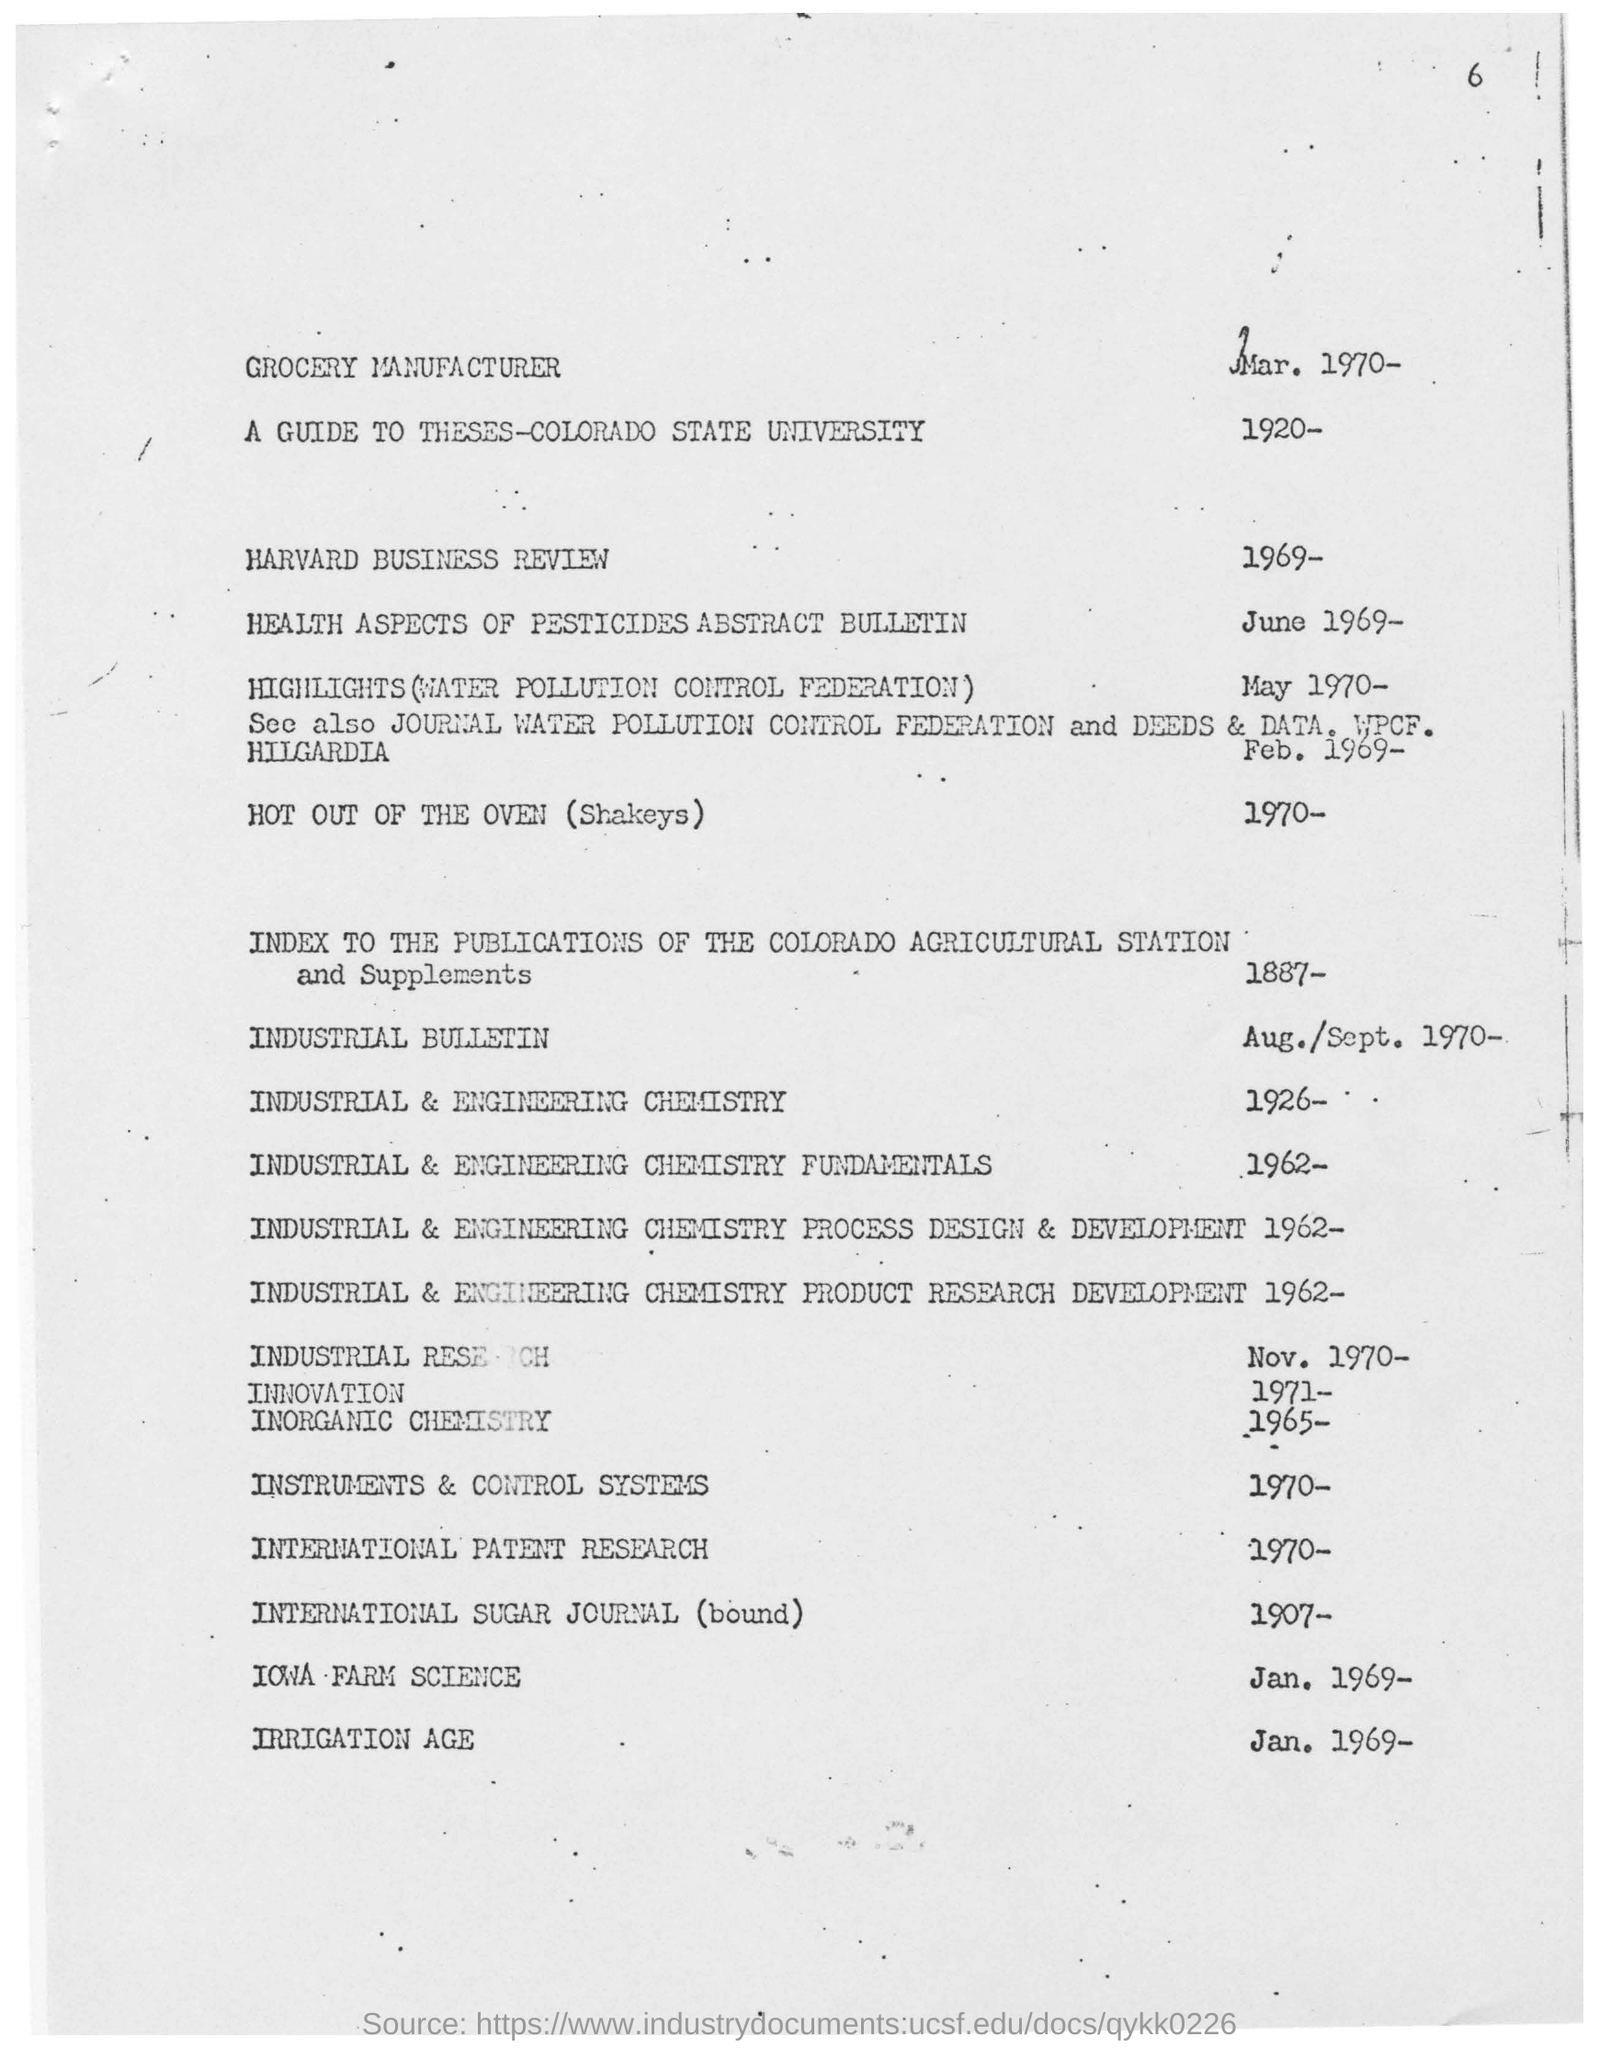What is the irrigation age mentioned in the given page ?
Give a very brief answer. Jan. 1969. What is the year mentioned for iowa-farm science ?
Your response must be concise. 1969. What is the year mentioned for harvard business review ?
Your answer should be compact. 1969. What is the year mentioned for grocery manufacturer ?
Keep it short and to the point. 1970. 